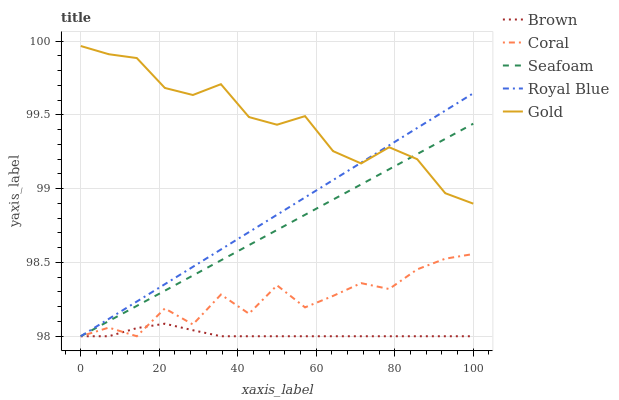Does Brown have the minimum area under the curve?
Answer yes or no. Yes. Does Gold have the maximum area under the curve?
Answer yes or no. Yes. Does Coral have the minimum area under the curve?
Answer yes or no. No. Does Coral have the maximum area under the curve?
Answer yes or no. No. Is Royal Blue the smoothest?
Answer yes or no. Yes. Is Coral the roughest?
Answer yes or no. Yes. Is Seafoam the smoothest?
Answer yes or no. No. Is Seafoam the roughest?
Answer yes or no. No. Does Brown have the lowest value?
Answer yes or no. Yes. Does Gold have the lowest value?
Answer yes or no. No. Does Gold have the highest value?
Answer yes or no. Yes. Does Coral have the highest value?
Answer yes or no. No. Is Brown less than Gold?
Answer yes or no. Yes. Is Gold greater than Coral?
Answer yes or no. Yes. Does Coral intersect Seafoam?
Answer yes or no. Yes. Is Coral less than Seafoam?
Answer yes or no. No. Is Coral greater than Seafoam?
Answer yes or no. No. Does Brown intersect Gold?
Answer yes or no. No. 